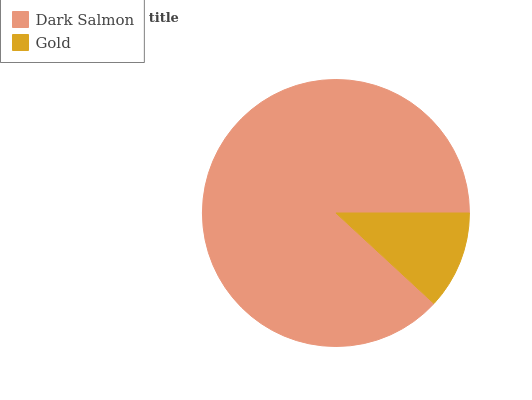Is Gold the minimum?
Answer yes or no. Yes. Is Dark Salmon the maximum?
Answer yes or no. Yes. Is Gold the maximum?
Answer yes or no. No. Is Dark Salmon greater than Gold?
Answer yes or no. Yes. Is Gold less than Dark Salmon?
Answer yes or no. Yes. Is Gold greater than Dark Salmon?
Answer yes or no. No. Is Dark Salmon less than Gold?
Answer yes or no. No. Is Dark Salmon the high median?
Answer yes or no. Yes. Is Gold the low median?
Answer yes or no. Yes. Is Gold the high median?
Answer yes or no. No. Is Dark Salmon the low median?
Answer yes or no. No. 